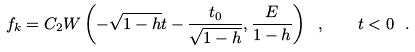<formula> <loc_0><loc_0><loc_500><loc_500>f _ { k } = C _ { 2 } W \left ( - \sqrt { 1 - h } t - \frac { t _ { 0 } } { \sqrt { 1 - h } } , \frac { E } { 1 - h } \right ) \ , \quad t < 0 \ .</formula> 